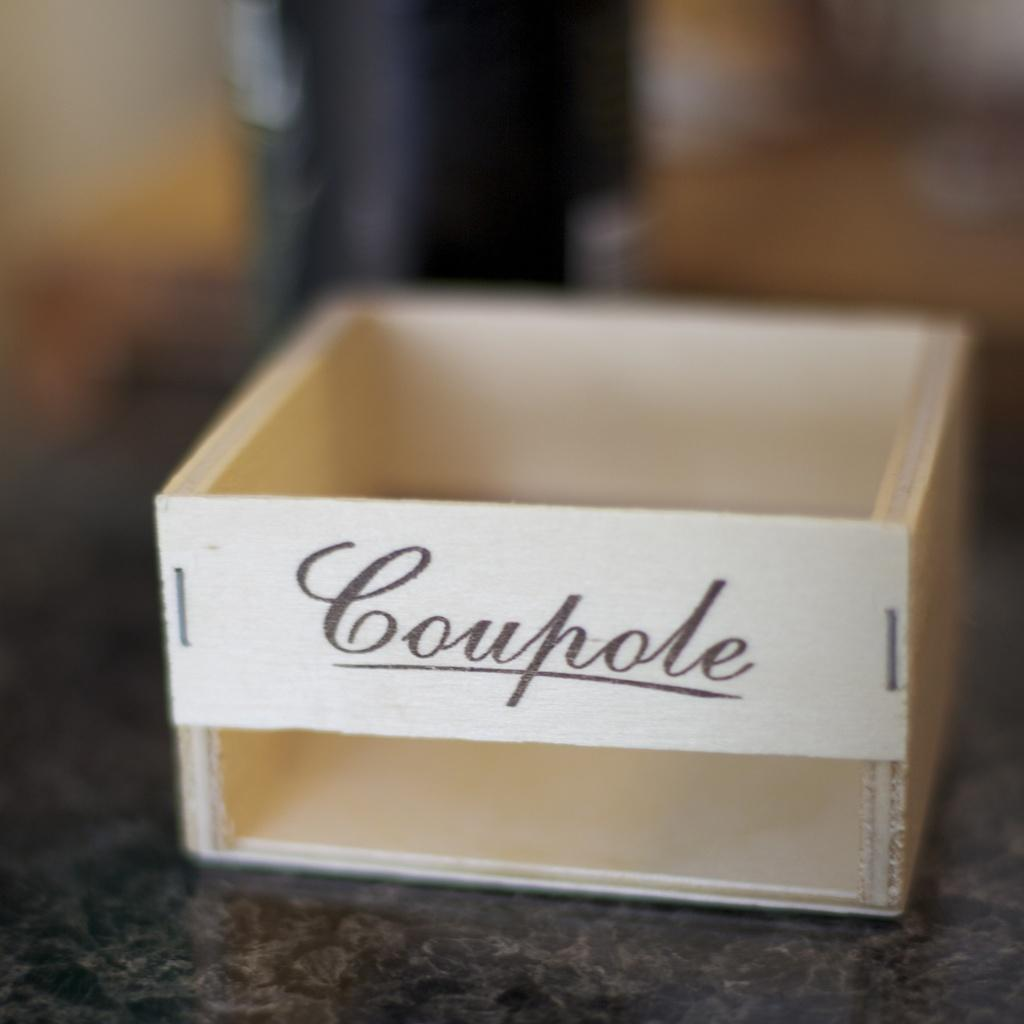<image>
Write a terse but informative summary of the picture. a small box has no top, and the word Coupole on it 